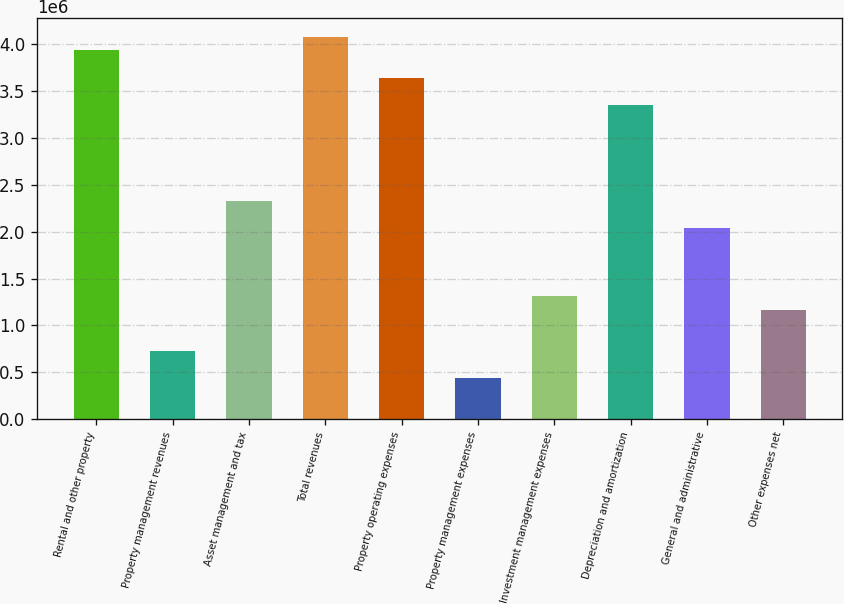Convert chart to OTSL. <chart><loc_0><loc_0><loc_500><loc_500><bar_chart><fcel>Rental and other property<fcel>Property management revenues<fcel>Asset management and tax<fcel>Total revenues<fcel>Property operating expenses<fcel>Property management expenses<fcel>Investment management expenses<fcel>Depreciation and amortization<fcel>General and administrative<fcel>Other expenses net<nl><fcel>3.93638e+06<fcel>728960<fcel>2.33267e+06<fcel>4.08217e+06<fcel>3.64479e+06<fcel>437376<fcel>1.31213e+06<fcel>3.35321e+06<fcel>2.04108e+06<fcel>1.16633e+06<nl></chart> 